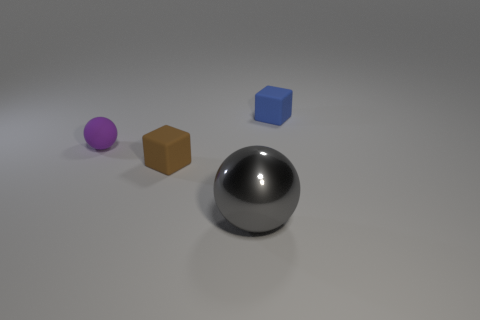Subtract all purple spheres. How many spheres are left? 1 Add 4 purple rubber objects. How many objects exist? 8 Subtract 2 balls. How many balls are left? 0 Add 3 small blue cubes. How many small blue cubes are left? 4 Add 2 brown rubber things. How many brown rubber things exist? 3 Subtract 0 purple blocks. How many objects are left? 4 Subtract all brown balls. Subtract all purple cubes. How many balls are left? 2 Subtract all metal balls. Subtract all small gray metal cubes. How many objects are left? 3 